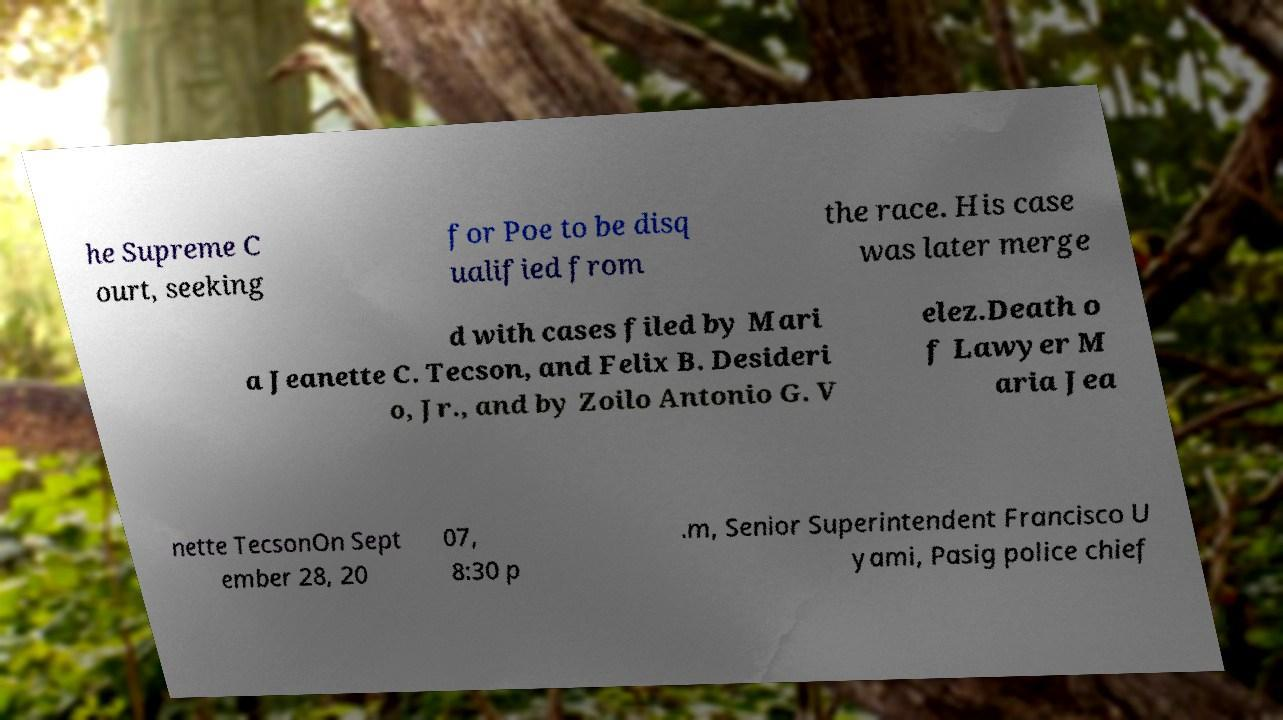Could you extract and type out the text from this image? he Supreme C ourt, seeking for Poe to be disq ualified from the race. His case was later merge d with cases filed by Mari a Jeanette C. Tecson, and Felix B. Desideri o, Jr., and by Zoilo Antonio G. V elez.Death o f Lawyer M aria Jea nette TecsonOn Sept ember 28, 20 07, 8:30 p .m, Senior Superintendent Francisco U yami, Pasig police chief 